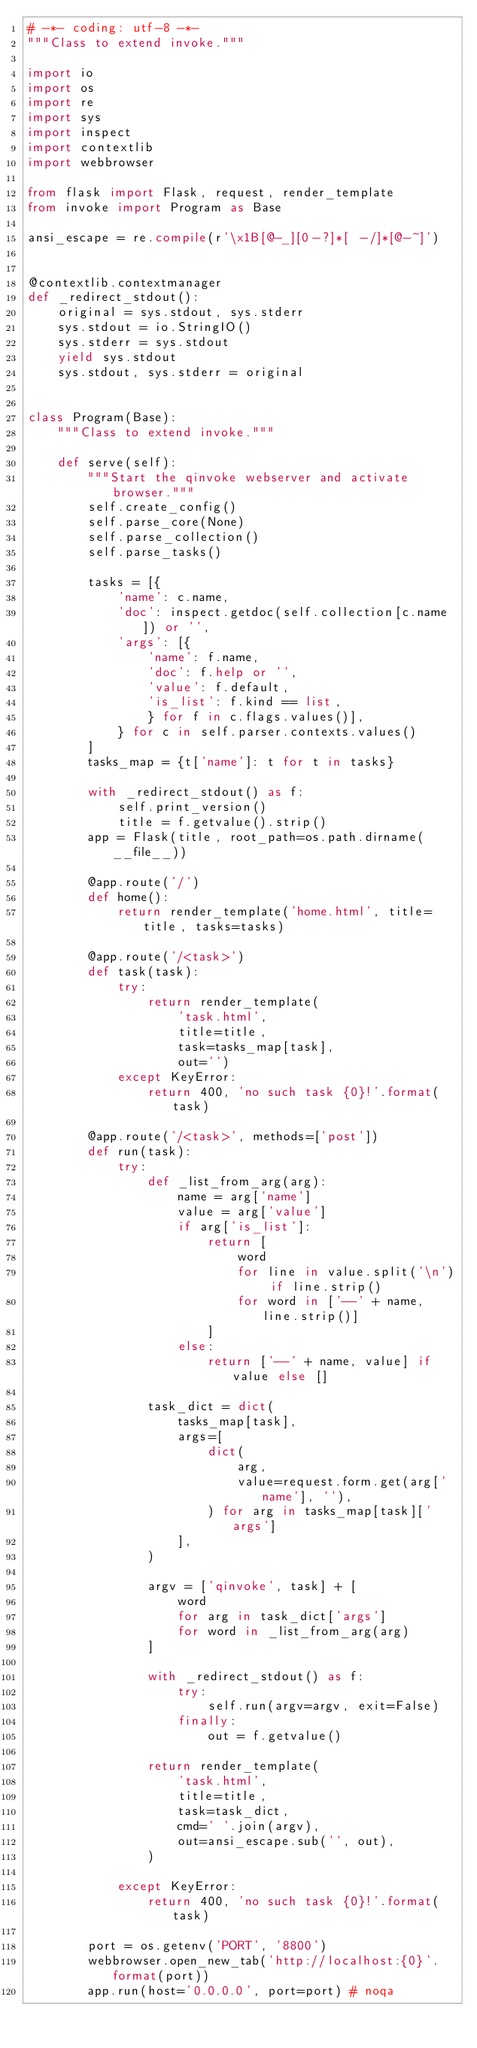Convert code to text. <code><loc_0><loc_0><loc_500><loc_500><_Python_># -*- coding: utf-8 -*-
"""Class to extend invoke."""

import io
import os
import re
import sys
import inspect
import contextlib
import webbrowser

from flask import Flask, request, render_template
from invoke import Program as Base

ansi_escape = re.compile(r'\x1B[@-_][0-?]*[ -/]*[@-~]')


@contextlib.contextmanager
def _redirect_stdout():
    original = sys.stdout, sys.stderr
    sys.stdout = io.StringIO()
    sys.stderr = sys.stdout
    yield sys.stdout
    sys.stdout, sys.stderr = original


class Program(Base):
    """Class to extend invoke."""

    def serve(self):
        """Start the qinvoke webserver and activate browser."""
        self.create_config()
        self.parse_core(None)
        self.parse_collection()
        self.parse_tasks()

        tasks = [{
            'name': c.name,
            'doc': inspect.getdoc(self.collection[c.name]) or '',
            'args': [{
                'name': f.name,
                'doc': f.help or '',
                'value': f.default,
                'is_list': f.kind == list,
                } for f in c.flags.values()],
            } for c in self.parser.contexts.values()
        ]
        tasks_map = {t['name']: t for t in tasks}

        with _redirect_stdout() as f:
            self.print_version()
            title = f.getvalue().strip()
        app = Flask(title, root_path=os.path.dirname(__file__))

        @app.route('/')
        def home():
            return render_template('home.html', title=title, tasks=tasks)

        @app.route('/<task>')
        def task(task):
            try:
                return render_template(
                    'task.html',
                    title=title,
                    task=tasks_map[task],
                    out='')
            except KeyError:
                return 400, 'no such task {0}!'.format(task)

        @app.route('/<task>', methods=['post'])
        def run(task):
            try:
                def _list_from_arg(arg):
                    name = arg['name']
                    value = arg['value']
                    if arg['is_list']:
                        return [
                            word
                            for line in value.split('\n') if line.strip()
                            for word in ['--' + name, line.strip()]
                        ]
                    else:
                        return ['--' + name, value] if value else []

                task_dict = dict(
                    tasks_map[task],
                    args=[
                        dict(
                            arg,
                            value=request.form.get(arg['name'], ''),
                        ) for arg in tasks_map[task]['args']
                    ],
                )

                argv = ['qinvoke', task] + [
                    word
                    for arg in task_dict['args']
                    for word in _list_from_arg(arg)
                ]

                with _redirect_stdout() as f:
                    try:
                        self.run(argv=argv, exit=False)
                    finally:
                        out = f.getvalue()

                return render_template(
                    'task.html',
                    title=title,
                    task=task_dict,
                    cmd=' '.join(argv),
                    out=ansi_escape.sub('', out),
                )

            except KeyError:
                return 400, 'no such task {0}!'.format(task)

        port = os.getenv('PORT', '8800')
        webbrowser.open_new_tab('http://localhost:{0}'.format(port))
        app.run(host='0.0.0.0', port=port) # noqa
</code> 